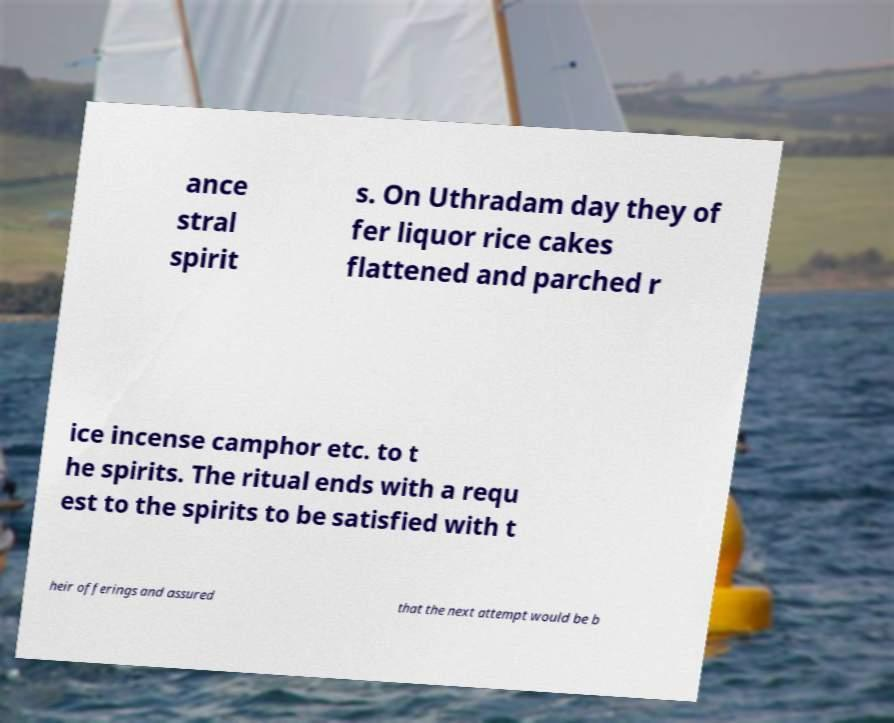Can you accurately transcribe the text from the provided image for me? ance stral spirit s. On Uthradam day they of fer liquor rice cakes flattened and parched r ice incense camphor etc. to t he spirits. The ritual ends with a requ est to the spirits to be satisfied with t heir offerings and assured that the next attempt would be b 